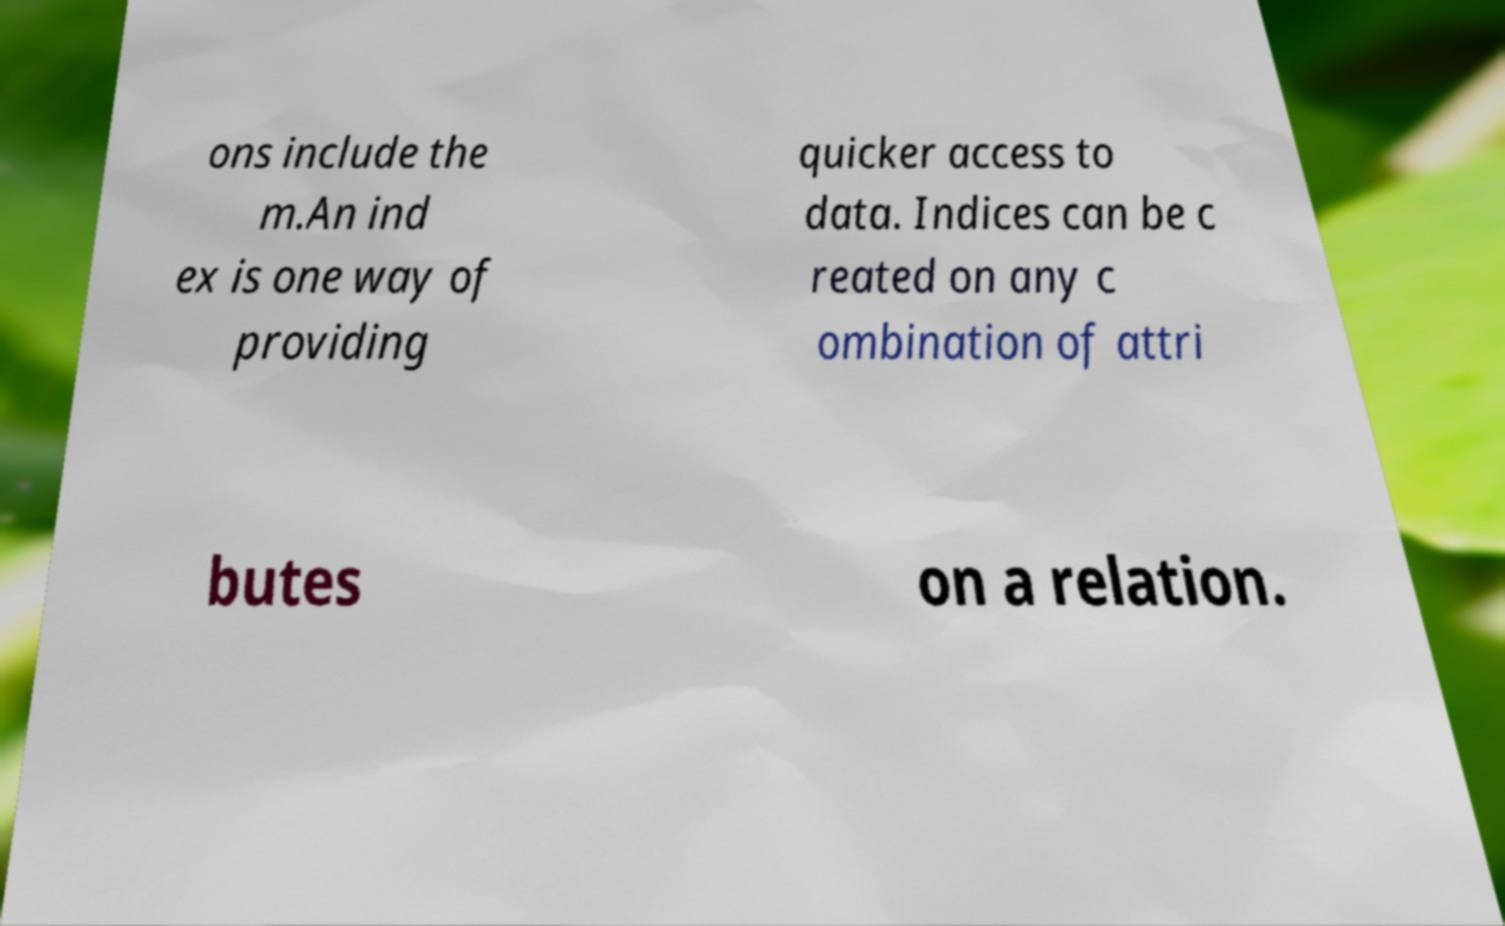Can you read and provide the text displayed in the image?This photo seems to have some interesting text. Can you extract and type it out for me? ons include the m.An ind ex is one way of providing quicker access to data. Indices can be c reated on any c ombination of attri butes on a relation. 